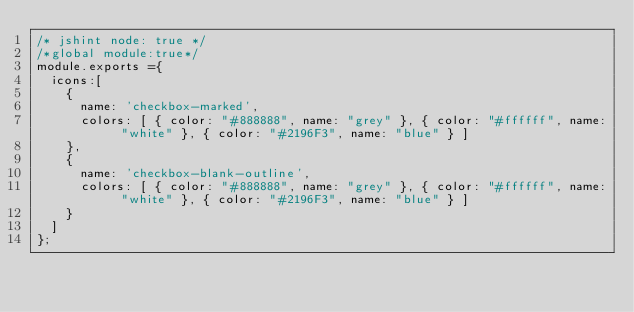Convert code to text. <code><loc_0><loc_0><loc_500><loc_500><_JavaScript_>/* jshint node: true */
/*global module:true*/
module.exports ={
  icons:[
    {
      name: 'checkbox-marked',
      colors: [ { color: "#888888", name: "grey" }, { color: "#ffffff", name: "white" }, { color: "#2196F3", name: "blue" } ]
    },
    {
      name: 'checkbox-blank-outline',
      colors: [ { color: "#888888", name: "grey" }, { color: "#ffffff", name: "white" }, { color: "#2196F3", name: "blue" } ]
    }
  ]
};
</code> 